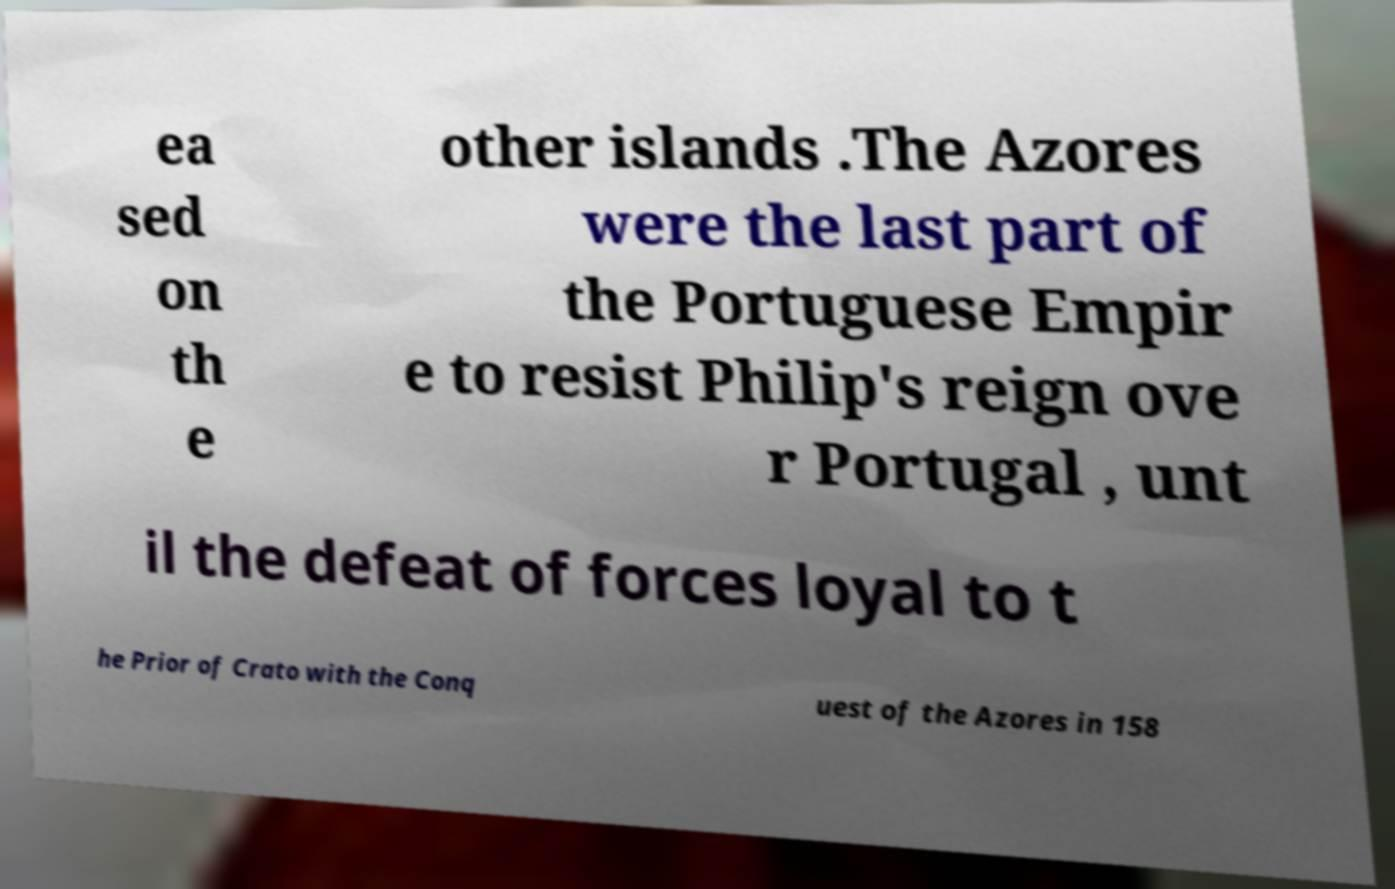I need the written content from this picture converted into text. Can you do that? ea sed on th e other islands .The Azores were the last part of the Portuguese Empir e to resist Philip's reign ove r Portugal , unt il the defeat of forces loyal to t he Prior of Crato with the Conq uest of the Azores in 158 